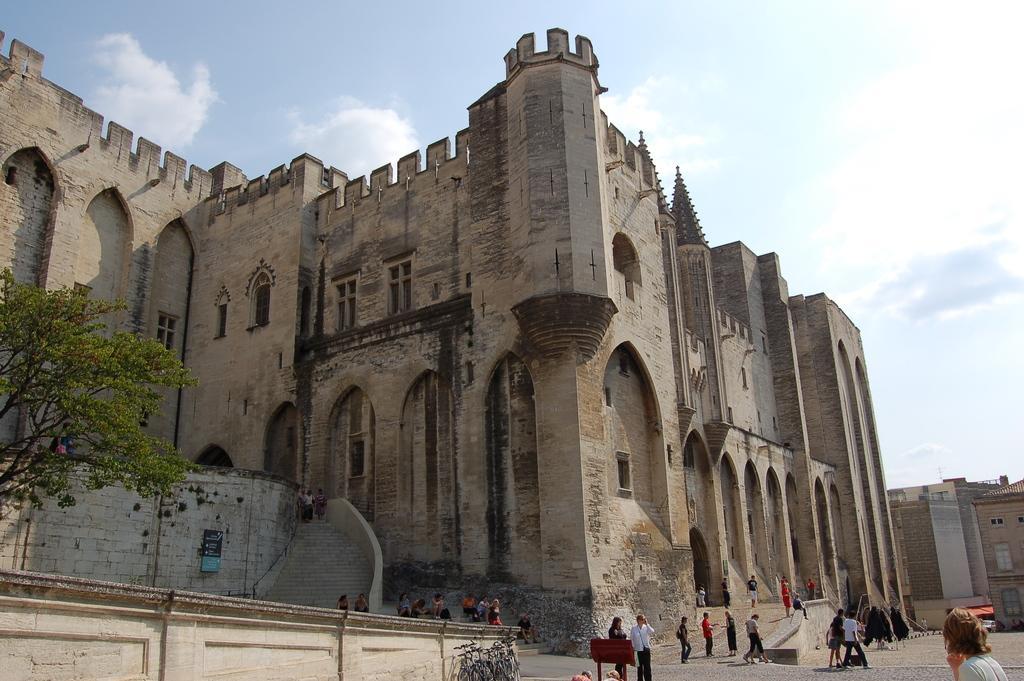Describe this image in one or two sentences. In this image we can see heritage building, people, stairs, plants and in the background we can see the sky. 